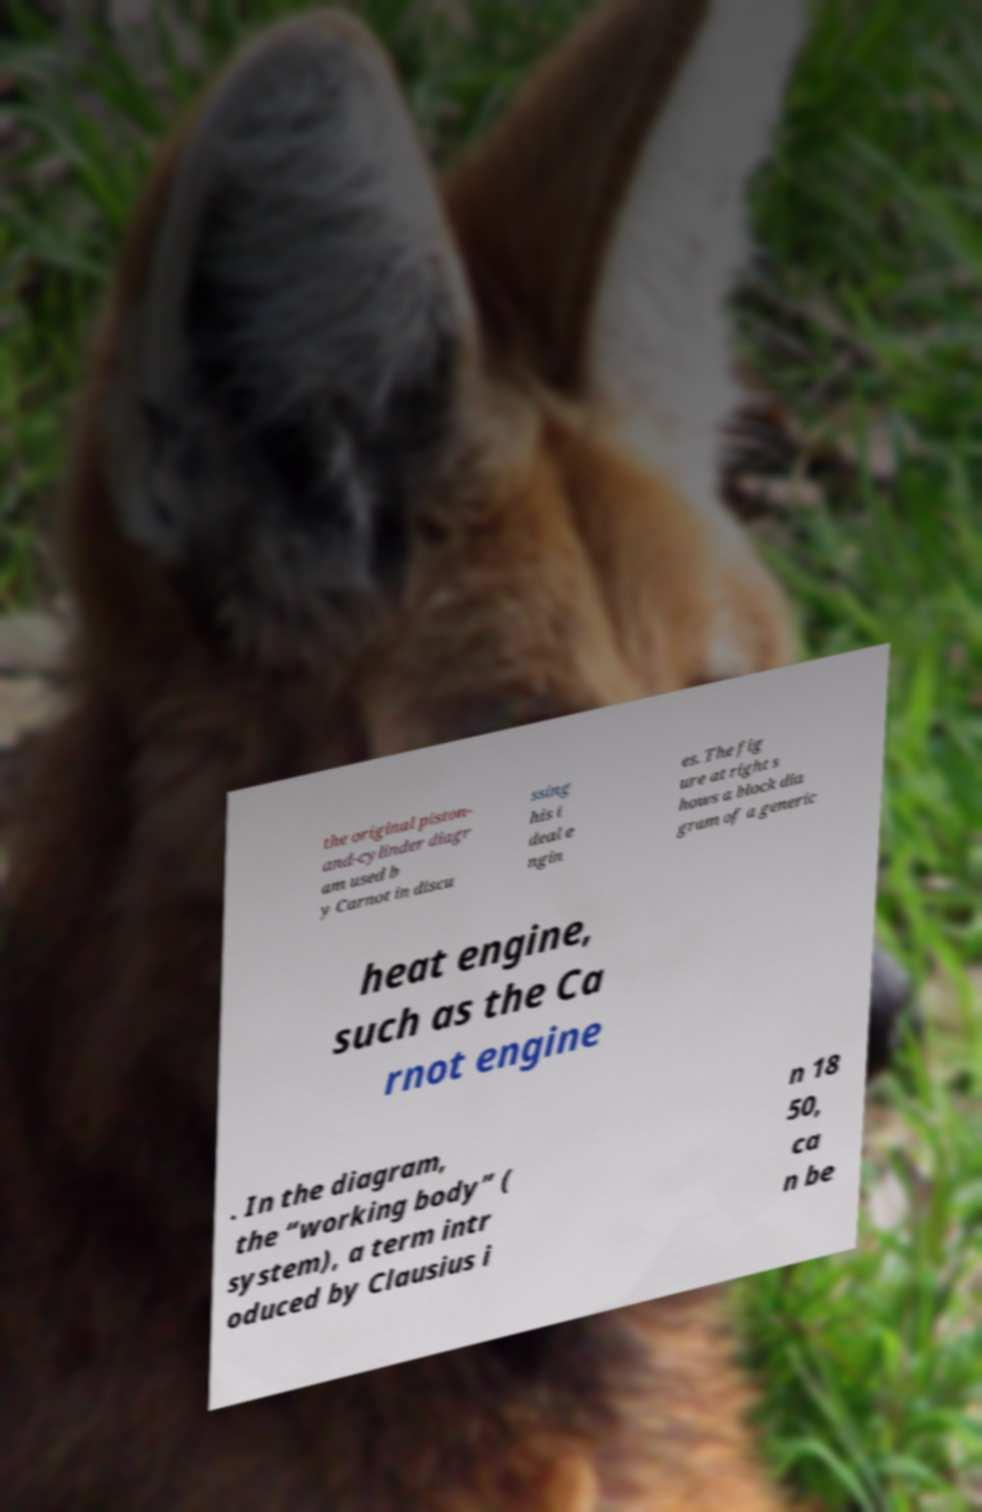Could you assist in decoding the text presented in this image and type it out clearly? the original piston- and-cylinder diagr am used b y Carnot in discu ssing his i deal e ngin es. The fig ure at right s hows a block dia gram of a generic heat engine, such as the Ca rnot engine . In the diagram, the “working body” ( system), a term intr oduced by Clausius i n 18 50, ca n be 